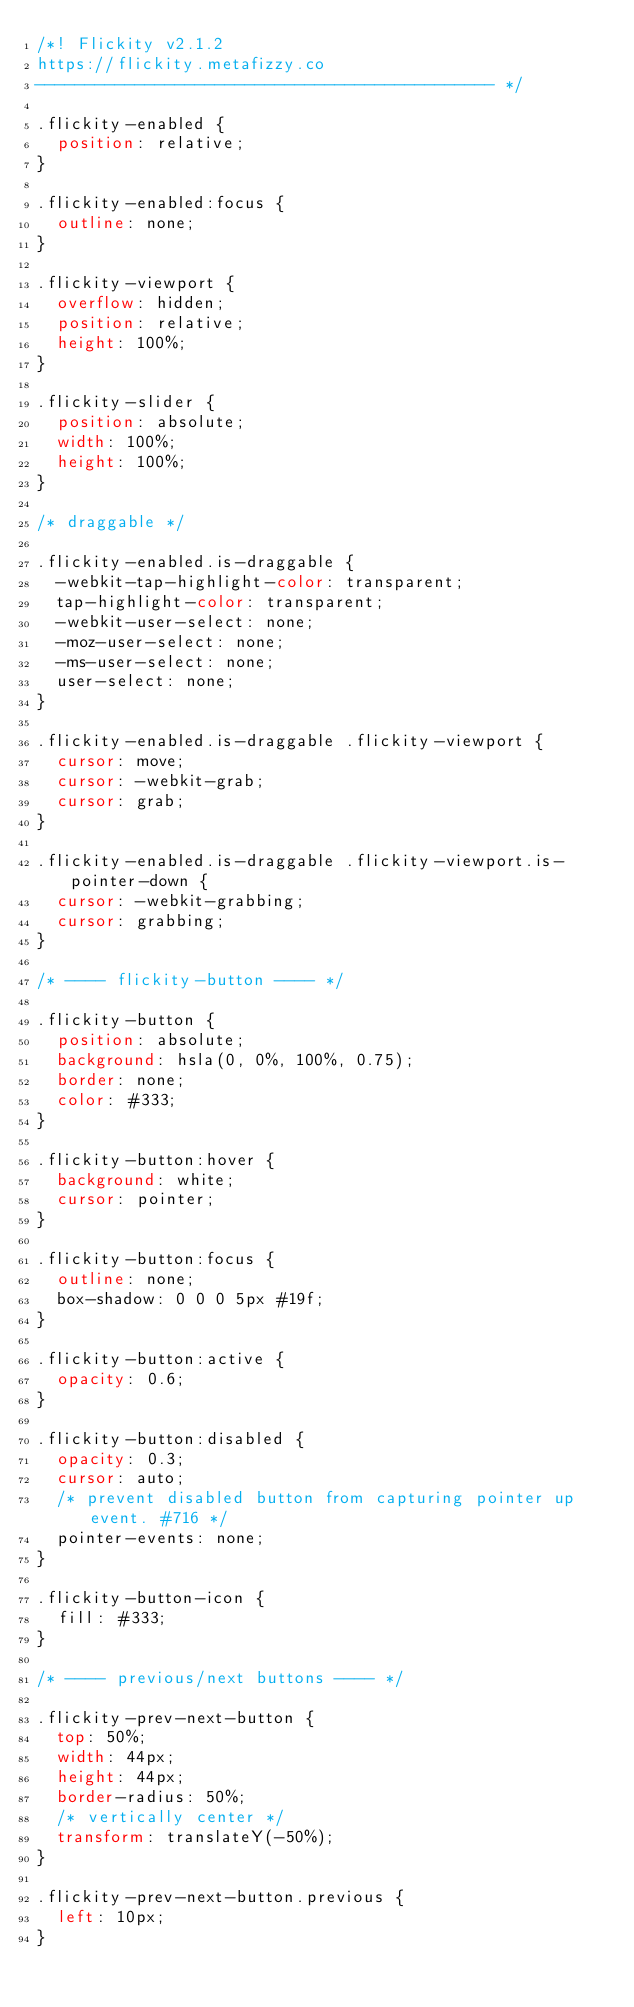Convert code to text. <code><loc_0><loc_0><loc_500><loc_500><_CSS_>/*! Flickity v2.1.2
https://flickity.metafizzy.co
---------------------------------------------- */

.flickity-enabled {
  position: relative;
}

.flickity-enabled:focus {
  outline: none;
}

.flickity-viewport {
  overflow: hidden;
  position: relative;
  height: 100%;
}

.flickity-slider {
  position: absolute;
  width: 100%;
  height: 100%;
}

/* draggable */

.flickity-enabled.is-draggable {
  -webkit-tap-highlight-color: transparent;
  tap-highlight-color: transparent;
  -webkit-user-select: none;
  -moz-user-select: none;
  -ms-user-select: none;
  user-select: none;
}

.flickity-enabled.is-draggable .flickity-viewport {
  cursor: move;
  cursor: -webkit-grab;
  cursor: grab;
}

.flickity-enabled.is-draggable .flickity-viewport.is-pointer-down {
  cursor: -webkit-grabbing;
  cursor: grabbing;
}

/* ---- flickity-button ---- */

.flickity-button {
  position: absolute;
  background: hsla(0, 0%, 100%, 0.75);
  border: none;
  color: #333;
}

.flickity-button:hover {
  background: white;
  cursor: pointer;
}

.flickity-button:focus {
  outline: none;
  box-shadow: 0 0 0 5px #19f;
}

.flickity-button:active {
  opacity: 0.6;
}

.flickity-button:disabled {
  opacity: 0.3;
  cursor: auto;
  /* prevent disabled button from capturing pointer up event. #716 */
  pointer-events: none;
}

.flickity-button-icon {
  fill: #333;
}

/* ---- previous/next buttons ---- */

.flickity-prev-next-button {
  top: 50%;
  width: 44px;
  height: 44px;
  border-radius: 50%;
  /* vertically center */
  transform: translateY(-50%);
}

.flickity-prev-next-button.previous {
  left: 10px;
}</code> 